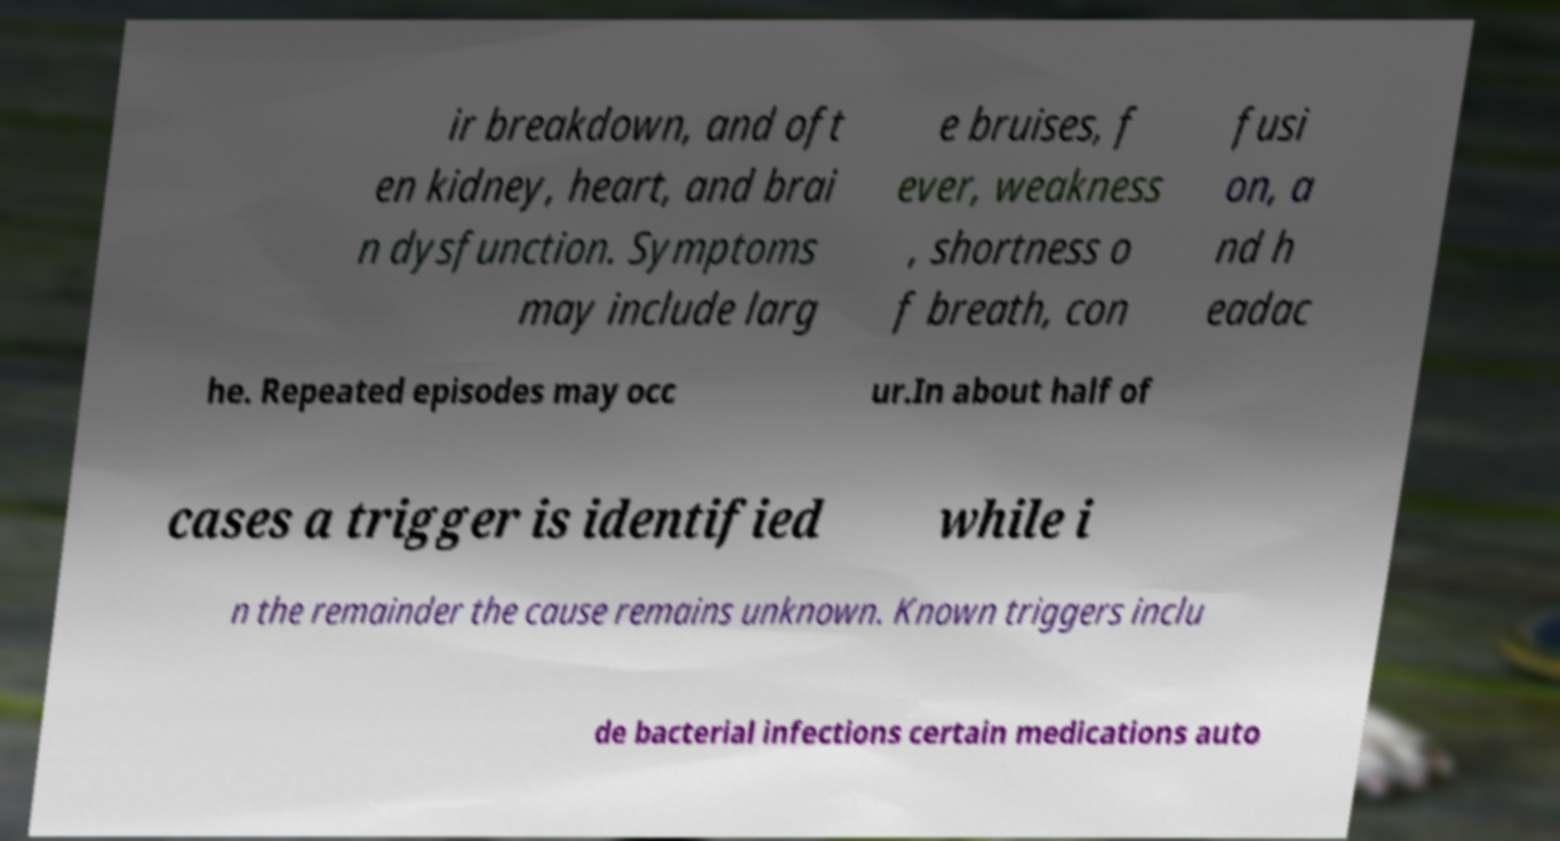I need the written content from this picture converted into text. Can you do that? ir breakdown, and oft en kidney, heart, and brai n dysfunction. Symptoms may include larg e bruises, f ever, weakness , shortness o f breath, con fusi on, a nd h eadac he. Repeated episodes may occ ur.In about half of cases a trigger is identified while i n the remainder the cause remains unknown. Known triggers inclu de bacterial infections certain medications auto 